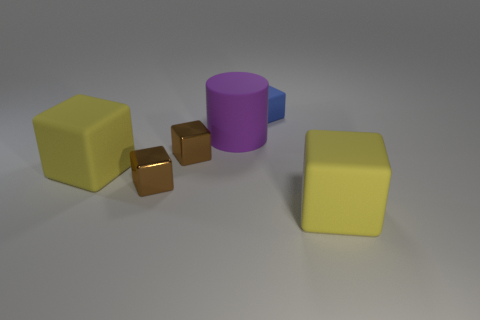What number of other things are there of the same material as the large cylinder
Keep it short and to the point. 3. Are there an equal number of large purple cylinders that are to the right of the big purple cylinder and large gray metallic blocks?
Provide a short and direct response. Yes. Does the purple object have the same size as the rubber object on the left side of the matte cylinder?
Your response must be concise. Yes. What shape is the yellow matte thing to the right of the big purple matte object?
Provide a succinct answer. Cube. Are there any other things that are the same shape as the small blue rubber object?
Your response must be concise. Yes. Is there a blue rubber object?
Your response must be concise. Yes. Does the rubber object to the left of the cylinder have the same size as the yellow block that is to the right of the matte cylinder?
Offer a very short reply. Yes. There is a big purple thing; what number of objects are to the left of it?
Provide a short and direct response. 3. Is there any other thing that has the same size as the cylinder?
Keep it short and to the point. Yes. What color is the cylinder that is made of the same material as the blue cube?
Offer a terse response. Purple. 